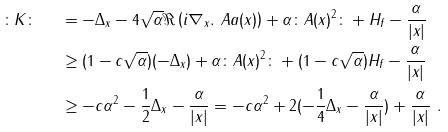Convert formula to latex. <formula><loc_0><loc_0><loc_500><loc_500>\colon K \colon \ \ & = - \Delta _ { x } - 4 \sqrt { \alpha } \Re \left ( i \nabla _ { x } . \ A a ( x ) \right ) + \alpha \colon A ( x ) ^ { 2 } \colon + H _ { f } - \frac { \alpha } { | x | } \\ & \geq ( 1 - c \sqrt { \alpha } ) ( - \Delta _ { x } ) + \alpha \colon A ( x ) ^ { 2 } \colon + ( 1 - c \sqrt { \alpha } ) H _ { f } - \frac { \alpha } { | x | } \\ & \geq - c \alpha ^ { 2 } - \frac { 1 } { 2 } \Delta _ { x } - \frac { \alpha } { | x | } = - c \alpha ^ { 2 } + 2 ( - \frac { 1 } { 4 } \Delta _ { x } - \frac { \alpha } { | x | } ) + \frac { \alpha } { | x | } \ .</formula> 